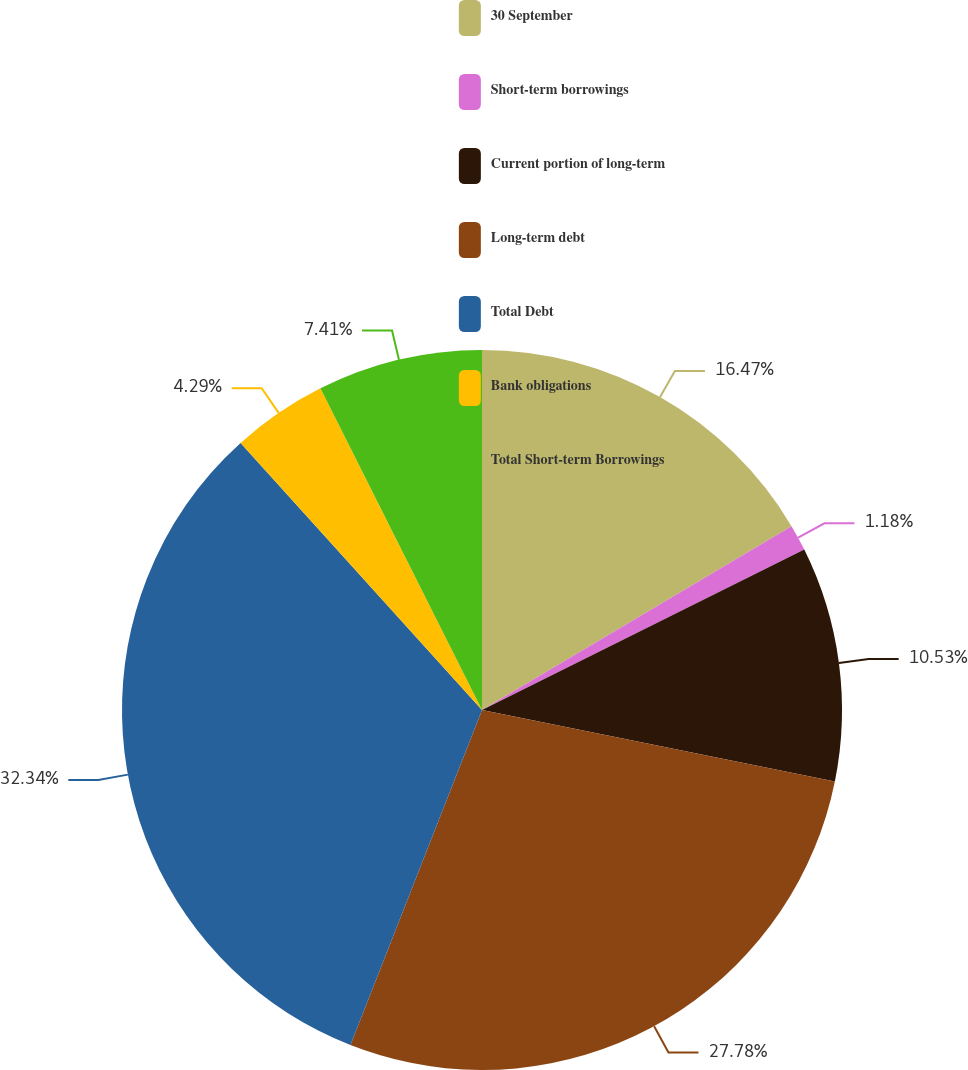Convert chart to OTSL. <chart><loc_0><loc_0><loc_500><loc_500><pie_chart><fcel>30 September<fcel>Short-term borrowings<fcel>Current portion of long-term<fcel>Long-term debt<fcel>Total Debt<fcel>Bank obligations<fcel>Total Short-term Borrowings<nl><fcel>16.47%<fcel>1.18%<fcel>10.53%<fcel>27.78%<fcel>32.35%<fcel>4.29%<fcel>7.41%<nl></chart> 